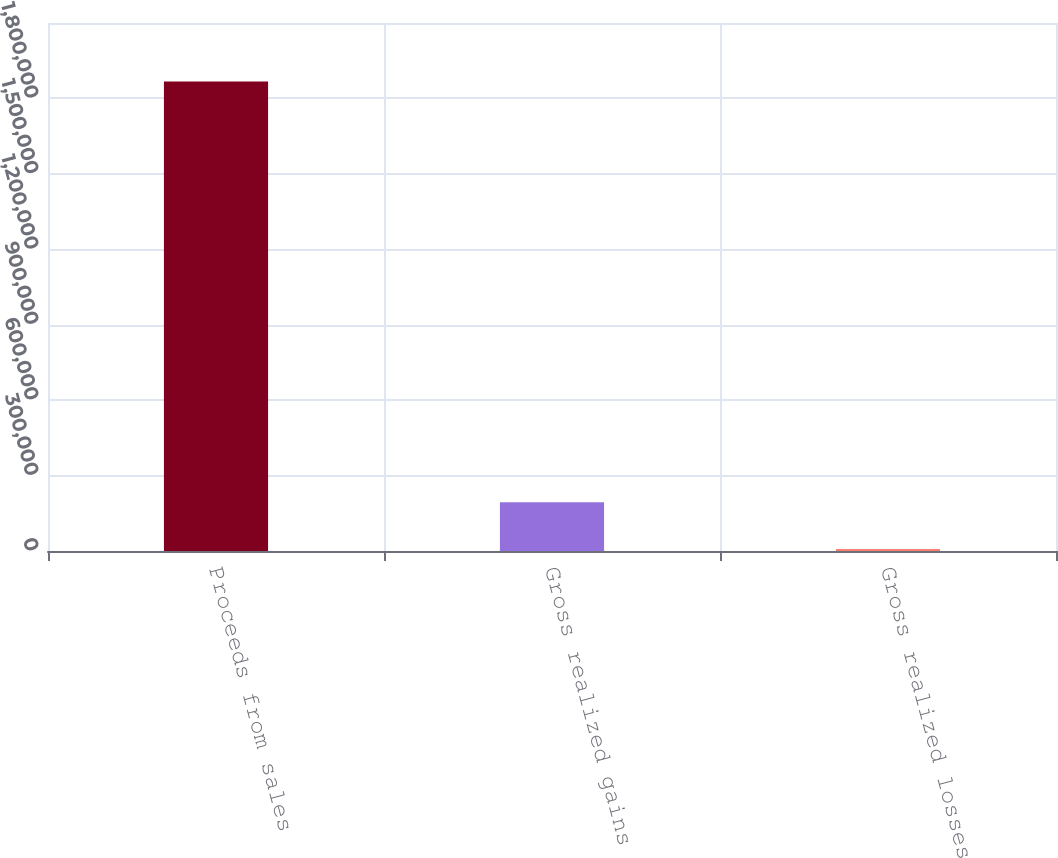<chart> <loc_0><loc_0><loc_500><loc_500><bar_chart><fcel>Proceeds from sales<fcel>Gross realized gains<fcel>Gross realized losses<nl><fcel>1.8678e+06<fcel>194237<fcel>8286<nl></chart> 